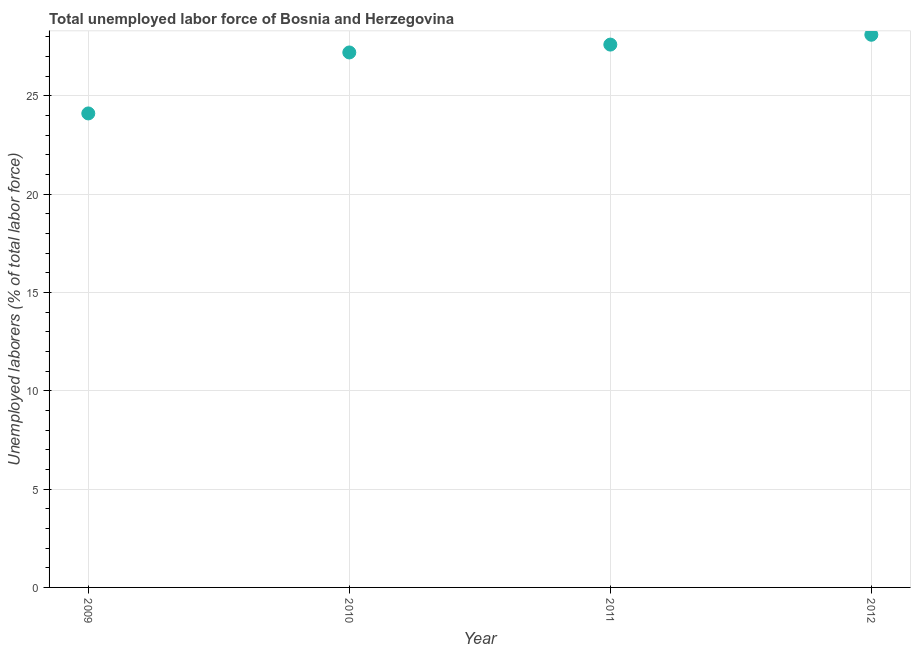What is the total unemployed labour force in 2009?
Ensure brevity in your answer.  24.1. Across all years, what is the maximum total unemployed labour force?
Your answer should be very brief. 28.1. Across all years, what is the minimum total unemployed labour force?
Your answer should be compact. 24.1. In which year was the total unemployed labour force maximum?
Ensure brevity in your answer.  2012. In which year was the total unemployed labour force minimum?
Give a very brief answer. 2009. What is the sum of the total unemployed labour force?
Offer a terse response. 107. What is the difference between the total unemployed labour force in 2009 and 2011?
Your answer should be compact. -3.5. What is the average total unemployed labour force per year?
Ensure brevity in your answer.  26.75. What is the median total unemployed labour force?
Keep it short and to the point. 27.4. In how many years, is the total unemployed labour force greater than 7 %?
Offer a terse response. 4. What is the ratio of the total unemployed labour force in 2010 to that in 2012?
Give a very brief answer. 0.97. Is the total unemployed labour force in 2009 less than that in 2012?
Your response must be concise. Yes. Is the difference between the total unemployed labour force in 2010 and 2012 greater than the difference between any two years?
Provide a short and direct response. No. What is the difference between the highest and the second highest total unemployed labour force?
Ensure brevity in your answer.  0.5. Are the values on the major ticks of Y-axis written in scientific E-notation?
Your answer should be very brief. No. Does the graph contain any zero values?
Offer a very short reply. No. Does the graph contain grids?
Ensure brevity in your answer.  Yes. What is the title of the graph?
Give a very brief answer. Total unemployed labor force of Bosnia and Herzegovina. What is the label or title of the X-axis?
Give a very brief answer. Year. What is the label or title of the Y-axis?
Give a very brief answer. Unemployed laborers (% of total labor force). What is the Unemployed laborers (% of total labor force) in 2009?
Make the answer very short. 24.1. What is the Unemployed laborers (% of total labor force) in 2010?
Your response must be concise. 27.2. What is the Unemployed laborers (% of total labor force) in 2011?
Your answer should be compact. 27.6. What is the Unemployed laborers (% of total labor force) in 2012?
Your answer should be compact. 28.1. What is the difference between the Unemployed laborers (% of total labor force) in 2009 and 2011?
Make the answer very short. -3.5. What is the difference between the Unemployed laborers (% of total labor force) in 2010 and 2011?
Provide a short and direct response. -0.4. What is the difference between the Unemployed laborers (% of total labor force) in 2010 and 2012?
Your answer should be compact. -0.9. What is the ratio of the Unemployed laborers (% of total labor force) in 2009 to that in 2010?
Give a very brief answer. 0.89. What is the ratio of the Unemployed laborers (% of total labor force) in 2009 to that in 2011?
Offer a terse response. 0.87. What is the ratio of the Unemployed laborers (% of total labor force) in 2009 to that in 2012?
Ensure brevity in your answer.  0.86. What is the ratio of the Unemployed laborers (% of total labor force) in 2010 to that in 2011?
Provide a short and direct response. 0.99. What is the ratio of the Unemployed laborers (% of total labor force) in 2010 to that in 2012?
Make the answer very short. 0.97. What is the ratio of the Unemployed laborers (% of total labor force) in 2011 to that in 2012?
Offer a terse response. 0.98. 